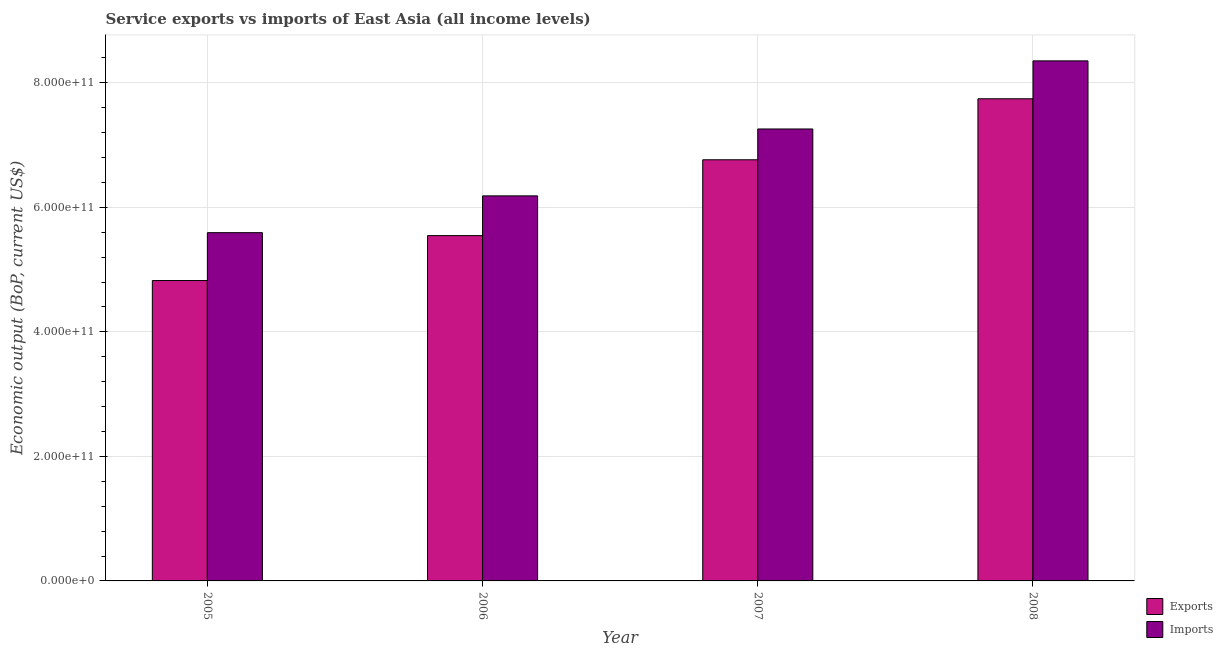How many different coloured bars are there?
Offer a very short reply. 2. How many groups of bars are there?
Your response must be concise. 4. Are the number of bars on each tick of the X-axis equal?
Ensure brevity in your answer.  Yes. How many bars are there on the 3rd tick from the left?
Keep it short and to the point. 2. How many bars are there on the 4th tick from the right?
Ensure brevity in your answer.  2. In how many cases, is the number of bars for a given year not equal to the number of legend labels?
Keep it short and to the point. 0. What is the amount of service exports in 2007?
Your response must be concise. 6.76e+11. Across all years, what is the maximum amount of service imports?
Your answer should be compact. 8.35e+11. Across all years, what is the minimum amount of service imports?
Give a very brief answer. 5.59e+11. What is the total amount of service exports in the graph?
Make the answer very short. 2.49e+12. What is the difference between the amount of service exports in 2007 and that in 2008?
Provide a succinct answer. -9.80e+1. What is the difference between the amount of service imports in 2005 and the amount of service exports in 2007?
Your answer should be compact. -1.66e+11. What is the average amount of service imports per year?
Keep it short and to the point. 6.85e+11. What is the ratio of the amount of service imports in 2005 to that in 2006?
Give a very brief answer. 0.9. Is the amount of service exports in 2005 less than that in 2006?
Give a very brief answer. Yes. Is the difference between the amount of service exports in 2005 and 2008 greater than the difference between the amount of service imports in 2005 and 2008?
Keep it short and to the point. No. What is the difference between the highest and the second highest amount of service exports?
Your answer should be compact. 9.80e+1. What is the difference between the highest and the lowest amount of service exports?
Offer a terse response. 2.92e+11. In how many years, is the amount of service exports greater than the average amount of service exports taken over all years?
Make the answer very short. 2. Is the sum of the amount of service imports in 2006 and 2007 greater than the maximum amount of service exports across all years?
Provide a short and direct response. Yes. What does the 2nd bar from the left in 2006 represents?
Your answer should be very brief. Imports. What does the 1st bar from the right in 2005 represents?
Keep it short and to the point. Imports. How many bars are there?
Provide a short and direct response. 8. What is the difference between two consecutive major ticks on the Y-axis?
Your answer should be compact. 2.00e+11. Does the graph contain any zero values?
Offer a terse response. No. Where does the legend appear in the graph?
Make the answer very short. Bottom right. What is the title of the graph?
Give a very brief answer. Service exports vs imports of East Asia (all income levels). Does "Canada" appear as one of the legend labels in the graph?
Your answer should be very brief. No. What is the label or title of the X-axis?
Your answer should be very brief. Year. What is the label or title of the Y-axis?
Make the answer very short. Economic output (BoP, current US$). What is the Economic output (BoP, current US$) in Exports in 2005?
Make the answer very short. 4.82e+11. What is the Economic output (BoP, current US$) in Imports in 2005?
Offer a terse response. 5.59e+11. What is the Economic output (BoP, current US$) of Exports in 2006?
Offer a terse response. 5.54e+11. What is the Economic output (BoP, current US$) in Imports in 2006?
Provide a succinct answer. 6.18e+11. What is the Economic output (BoP, current US$) of Exports in 2007?
Provide a succinct answer. 6.76e+11. What is the Economic output (BoP, current US$) of Imports in 2007?
Make the answer very short. 7.26e+11. What is the Economic output (BoP, current US$) of Exports in 2008?
Your answer should be very brief. 7.74e+11. What is the Economic output (BoP, current US$) of Imports in 2008?
Ensure brevity in your answer.  8.35e+11. Across all years, what is the maximum Economic output (BoP, current US$) in Exports?
Your answer should be compact. 7.74e+11. Across all years, what is the maximum Economic output (BoP, current US$) in Imports?
Provide a succinct answer. 8.35e+11. Across all years, what is the minimum Economic output (BoP, current US$) of Exports?
Keep it short and to the point. 4.82e+11. Across all years, what is the minimum Economic output (BoP, current US$) in Imports?
Ensure brevity in your answer.  5.59e+11. What is the total Economic output (BoP, current US$) in Exports in the graph?
Give a very brief answer. 2.49e+12. What is the total Economic output (BoP, current US$) in Imports in the graph?
Keep it short and to the point. 2.74e+12. What is the difference between the Economic output (BoP, current US$) in Exports in 2005 and that in 2006?
Offer a very short reply. -7.21e+1. What is the difference between the Economic output (BoP, current US$) in Imports in 2005 and that in 2006?
Offer a terse response. -5.91e+1. What is the difference between the Economic output (BoP, current US$) of Exports in 2005 and that in 2007?
Make the answer very short. -1.94e+11. What is the difference between the Economic output (BoP, current US$) of Imports in 2005 and that in 2007?
Ensure brevity in your answer.  -1.66e+11. What is the difference between the Economic output (BoP, current US$) in Exports in 2005 and that in 2008?
Your answer should be very brief. -2.92e+11. What is the difference between the Economic output (BoP, current US$) of Imports in 2005 and that in 2008?
Offer a very short reply. -2.76e+11. What is the difference between the Economic output (BoP, current US$) in Exports in 2006 and that in 2007?
Provide a succinct answer. -1.22e+11. What is the difference between the Economic output (BoP, current US$) in Imports in 2006 and that in 2007?
Your response must be concise. -1.07e+11. What is the difference between the Economic output (BoP, current US$) in Exports in 2006 and that in 2008?
Ensure brevity in your answer.  -2.20e+11. What is the difference between the Economic output (BoP, current US$) in Imports in 2006 and that in 2008?
Your answer should be very brief. -2.17e+11. What is the difference between the Economic output (BoP, current US$) of Exports in 2007 and that in 2008?
Offer a terse response. -9.80e+1. What is the difference between the Economic output (BoP, current US$) in Imports in 2007 and that in 2008?
Make the answer very short. -1.09e+11. What is the difference between the Economic output (BoP, current US$) in Exports in 2005 and the Economic output (BoP, current US$) in Imports in 2006?
Provide a short and direct response. -1.36e+11. What is the difference between the Economic output (BoP, current US$) in Exports in 2005 and the Economic output (BoP, current US$) in Imports in 2007?
Make the answer very short. -2.43e+11. What is the difference between the Economic output (BoP, current US$) in Exports in 2005 and the Economic output (BoP, current US$) in Imports in 2008?
Offer a very short reply. -3.53e+11. What is the difference between the Economic output (BoP, current US$) of Exports in 2006 and the Economic output (BoP, current US$) of Imports in 2007?
Give a very brief answer. -1.71e+11. What is the difference between the Economic output (BoP, current US$) of Exports in 2006 and the Economic output (BoP, current US$) of Imports in 2008?
Your answer should be compact. -2.81e+11. What is the difference between the Economic output (BoP, current US$) of Exports in 2007 and the Economic output (BoP, current US$) of Imports in 2008?
Provide a succinct answer. -1.59e+11. What is the average Economic output (BoP, current US$) in Exports per year?
Provide a short and direct response. 6.22e+11. What is the average Economic output (BoP, current US$) in Imports per year?
Provide a short and direct response. 6.85e+11. In the year 2005, what is the difference between the Economic output (BoP, current US$) in Exports and Economic output (BoP, current US$) in Imports?
Give a very brief answer. -7.69e+1. In the year 2006, what is the difference between the Economic output (BoP, current US$) of Exports and Economic output (BoP, current US$) of Imports?
Keep it short and to the point. -6.38e+1. In the year 2007, what is the difference between the Economic output (BoP, current US$) in Exports and Economic output (BoP, current US$) in Imports?
Your answer should be very brief. -4.94e+1. In the year 2008, what is the difference between the Economic output (BoP, current US$) of Exports and Economic output (BoP, current US$) of Imports?
Offer a terse response. -6.08e+1. What is the ratio of the Economic output (BoP, current US$) in Exports in 2005 to that in 2006?
Ensure brevity in your answer.  0.87. What is the ratio of the Economic output (BoP, current US$) of Imports in 2005 to that in 2006?
Offer a very short reply. 0.9. What is the ratio of the Economic output (BoP, current US$) in Exports in 2005 to that in 2007?
Offer a very short reply. 0.71. What is the ratio of the Economic output (BoP, current US$) in Imports in 2005 to that in 2007?
Make the answer very short. 0.77. What is the ratio of the Economic output (BoP, current US$) in Exports in 2005 to that in 2008?
Provide a short and direct response. 0.62. What is the ratio of the Economic output (BoP, current US$) in Imports in 2005 to that in 2008?
Make the answer very short. 0.67. What is the ratio of the Economic output (BoP, current US$) of Exports in 2006 to that in 2007?
Your response must be concise. 0.82. What is the ratio of the Economic output (BoP, current US$) in Imports in 2006 to that in 2007?
Give a very brief answer. 0.85. What is the ratio of the Economic output (BoP, current US$) of Exports in 2006 to that in 2008?
Give a very brief answer. 0.72. What is the ratio of the Economic output (BoP, current US$) in Imports in 2006 to that in 2008?
Keep it short and to the point. 0.74. What is the ratio of the Economic output (BoP, current US$) in Exports in 2007 to that in 2008?
Give a very brief answer. 0.87. What is the ratio of the Economic output (BoP, current US$) in Imports in 2007 to that in 2008?
Provide a succinct answer. 0.87. What is the difference between the highest and the second highest Economic output (BoP, current US$) of Exports?
Make the answer very short. 9.80e+1. What is the difference between the highest and the second highest Economic output (BoP, current US$) of Imports?
Provide a short and direct response. 1.09e+11. What is the difference between the highest and the lowest Economic output (BoP, current US$) of Exports?
Your answer should be compact. 2.92e+11. What is the difference between the highest and the lowest Economic output (BoP, current US$) in Imports?
Your answer should be compact. 2.76e+11. 